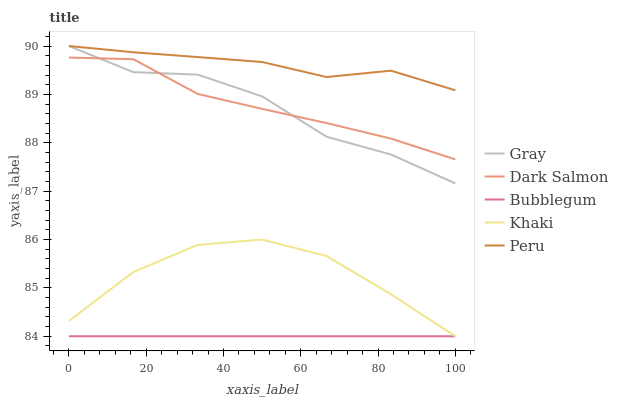Does Bubblegum have the minimum area under the curve?
Answer yes or no. Yes. Does Peru have the maximum area under the curve?
Answer yes or no. Yes. Does Gray have the minimum area under the curve?
Answer yes or no. No. Does Gray have the maximum area under the curve?
Answer yes or no. No. Is Bubblegum the smoothest?
Answer yes or no. Yes. Is Gray the roughest?
Answer yes or no. Yes. Is Khaki the smoothest?
Answer yes or no. No. Is Khaki the roughest?
Answer yes or no. No. Does Khaki have the lowest value?
Answer yes or no. Yes. Does Gray have the lowest value?
Answer yes or no. No. Does Gray have the highest value?
Answer yes or no. Yes. Does Khaki have the highest value?
Answer yes or no. No. Is Khaki less than Dark Salmon?
Answer yes or no. Yes. Is Gray greater than Bubblegum?
Answer yes or no. Yes. Does Peru intersect Gray?
Answer yes or no. Yes. Is Peru less than Gray?
Answer yes or no. No. Is Peru greater than Gray?
Answer yes or no. No. Does Khaki intersect Dark Salmon?
Answer yes or no. No. 